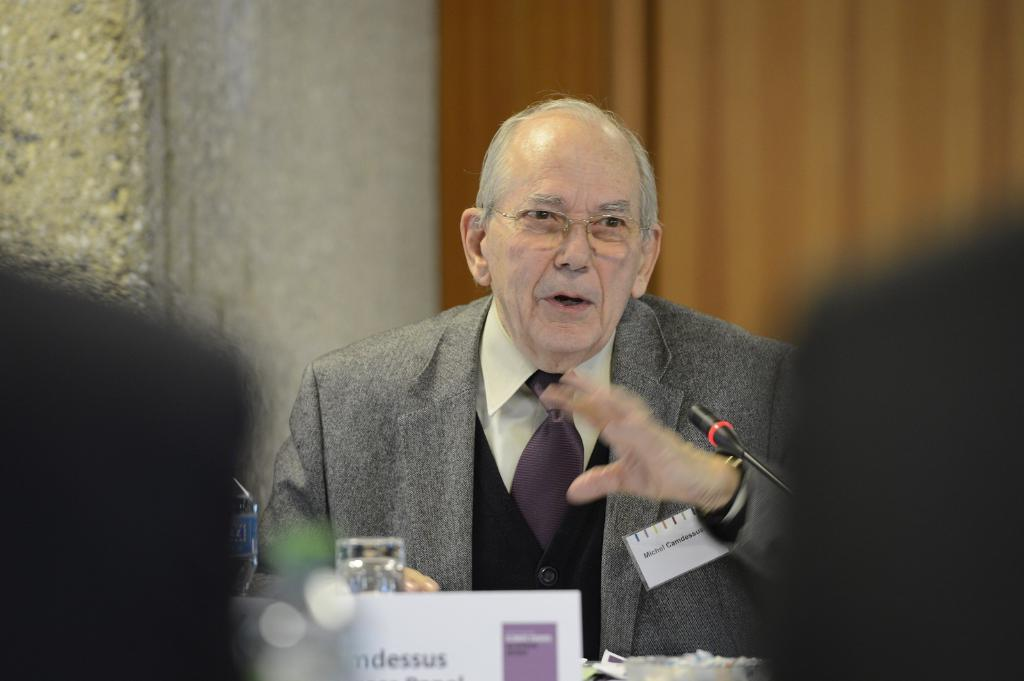<image>
Share a concise interpretation of the image provided. An old man speaking into a microphone and his nametag says Micheal. 